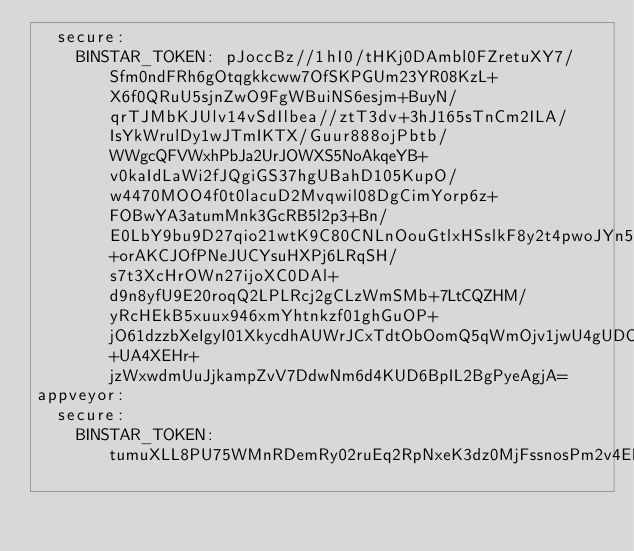Convert code to text. <code><loc_0><loc_0><loc_500><loc_500><_YAML_>  secure:
    BINSTAR_TOKEN: pJoccBz//1hI0/tHKj0DAmbl0FZretuXY7/Sfm0ndFRh6gOtqgkkcww7OfSKPGUm23YR08KzL+X6f0QRuU5sjnZwO9FgWBuiNS6esjm+BuyN/qrTJMbKJUlv14vSdIlbea//ztT3dv+3hJ165sTnCm2ILA/IsYkWrulDy1wJTmIKTX/Guur888ojPbtb/WWgcQFVWxhPbJa2UrJOWXS5NoAkqeYB+v0kaIdLaWi2fJQgiGS37hgUBahD105KupO/w4470MOO4f0t0lacuD2Mvqwil08DgCimYorp6z+FOBwYA3atumMnk3GcRB5l2p3+Bn/E0LbY9bu9D27qio21wtK9C80CNLnOouGtlxHSslkF8y2t4pwoJYn5q8k0h4WgMsLtURfdXhSoSwBSyC6ik8LlB95iiqAKKdSkD2eutbkSCZSreur2mHrBs16FU+orAKCJOfPNeJUCYsuHXPj6LRqSH/s7t3XcHrOWn27ijoXC0DAl+d9n8yfU9E20roqQ2LPLRcj2gCLzWmSMb+7LtCQZHM/yRcHEkB5xuux946xmYhtnkzf01ghGuOP+jO61dzzbXeIgyI01XkycdhAUWrJCxTdtObOomQ5qWmOjv1jwU4gUDOWmv+UA4XEHr+jzWxwdmUuJjkampZvV7DdwNm6d4KUD6BpIL2BgPyeAgjA=
appveyor:
  secure:
    BINSTAR_TOKEN: tumuXLL8PU75WMnRDemRy02ruEq2RpNxeK3dz0MjFssnosPm2v4EFjfNB4PTotA1
</code> 